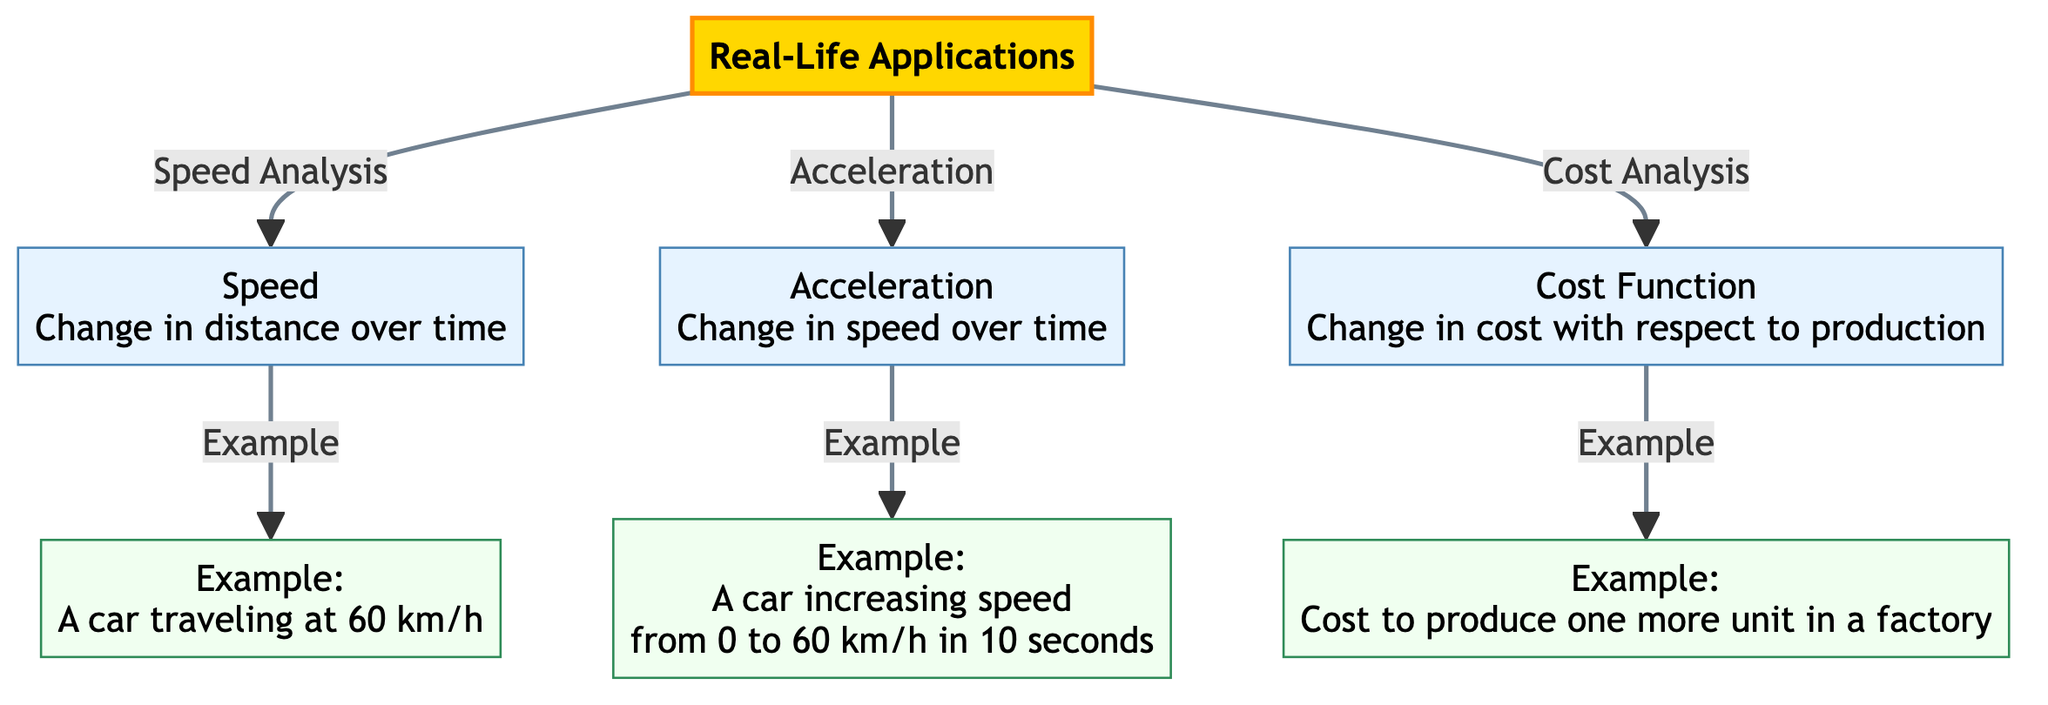What are the three main categories illustrated in the diagram? The diagram outlines three main categories connected to real-life applications: Speed Analysis, Acceleration, and Cost Analysis. Each category leads to an explanation about its context and an example.
Answer: Speed Analysis, Acceleration, Cost Analysis What does the Speed Explanation state? The Speed Explanation explains how speed is defined as the change in distance over time. This is fundamental to understanding how derivatives relate to speed in real-life situations.
Answer: Change in distance over time What is the example provided for Acceleration? The example for Acceleration illustrates a scenario where a car increases its speed from 0 to 60 km/h in 10 seconds, showing a practical application of acceleration concepts.
Answer: A car increasing speed from 0 to 60 km/h in 10 seconds How many examples are given in the diagram? There are three examples provided in the diagram, each demonstrating a different real-life application pertaining to speed, acceleration, and cost functions.
Answer: 3 What is the relationship between Cost Function Explanation and Cost Example? The Cost Function Explanation elaborates on how cost changes in relation to production, and it is directly followed by the Cost Example that illustrates the cost to produce one more unit in a factory. This demonstrates the practical application of the concept.
Answer: Cost Function Explanation leads to Cost Example Provide the speed of the car in the example under Speed Analysis. The Speed Example details that a car is traveling at a speed of 60 km/h, highlighting a specific instance of speed analysis that relates to derivatives in real life.
Answer: 60 km/h What is the text color used for the Cost Function Explanation? The Cost Function Explanation has a text color specified as black, which is consistent with the subtitle and fits the diagram's overall theme while being easily readable.
Answer: Black What type of analysis flows from Real-Life Applications to Acceleration Explanation? The analysis that flows from Real-Life Applications to Acceleration Explanation is focused on understanding how acceleration is defined, particularly as it relates to changes in speed over time in practical situations.
Answer: Acceleration 